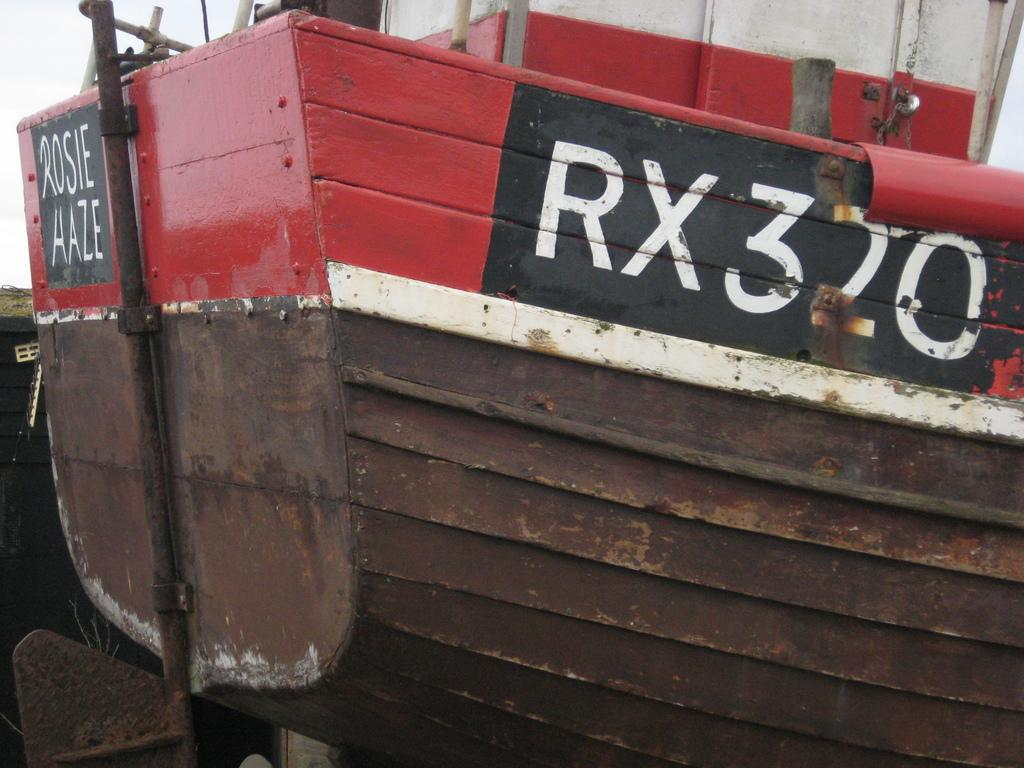What is the main subject of the image? There is a ship in the center of the image. Can you describe the ship in more detail? Unfortunately, the provided facts do not offer any additional details about the ship. Is there anything else visible in the image besides the ship? The facts do not mention any other objects or elements in the image. How many times has the ship been folded in the image? The ship cannot be folded, as it is a physical object and not a piece of paper or fabric. 